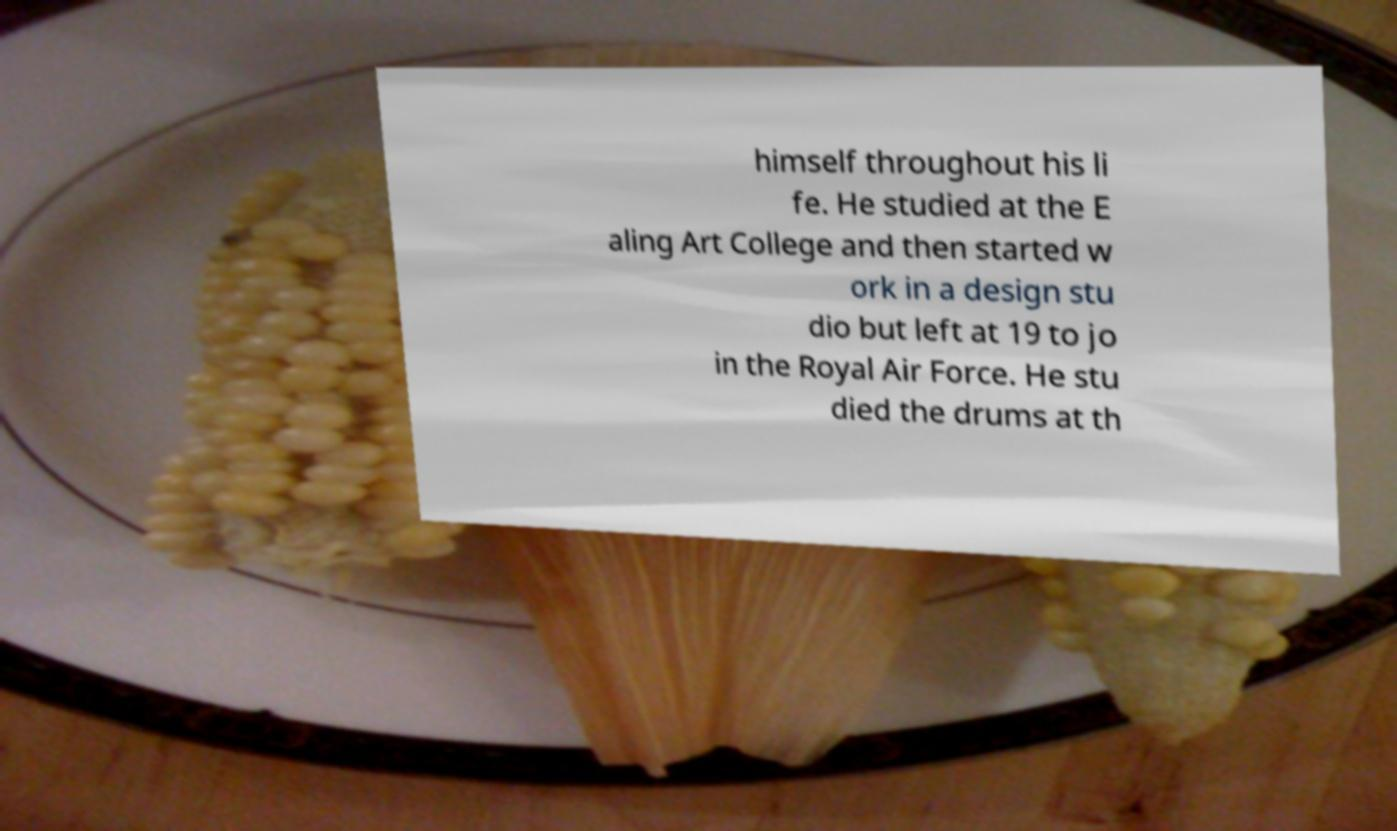Can you read and provide the text displayed in the image?This photo seems to have some interesting text. Can you extract and type it out for me? himself throughout his li fe. He studied at the E aling Art College and then started w ork in a design stu dio but left at 19 to jo in the Royal Air Force. He stu died the drums at th 